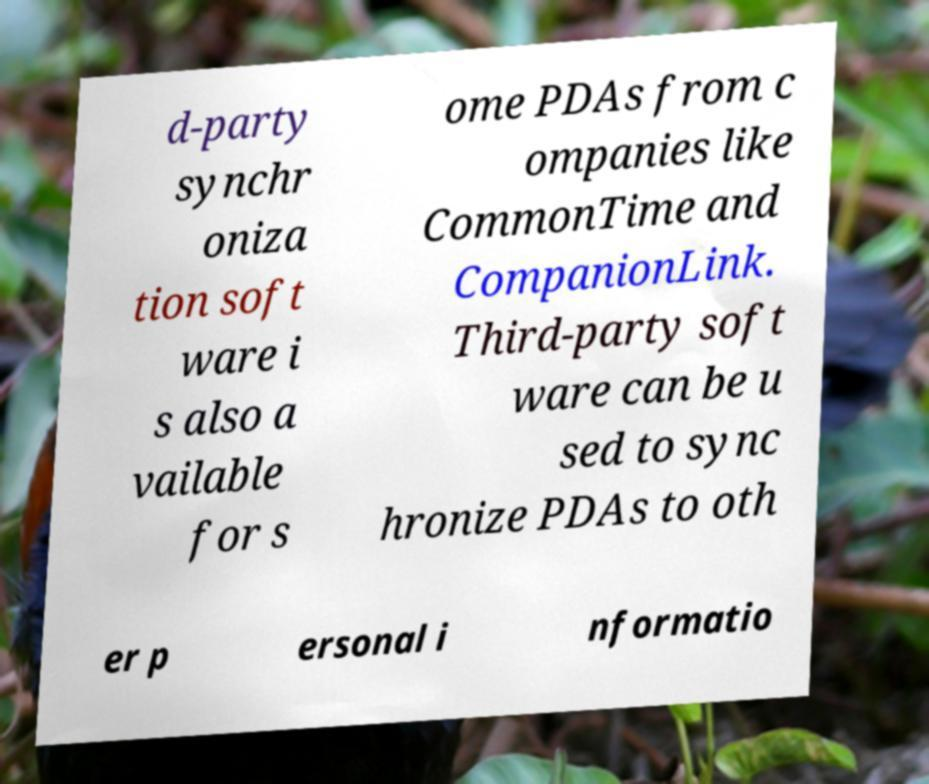Could you assist in decoding the text presented in this image and type it out clearly? d-party synchr oniza tion soft ware i s also a vailable for s ome PDAs from c ompanies like CommonTime and CompanionLink. Third-party soft ware can be u sed to sync hronize PDAs to oth er p ersonal i nformatio 